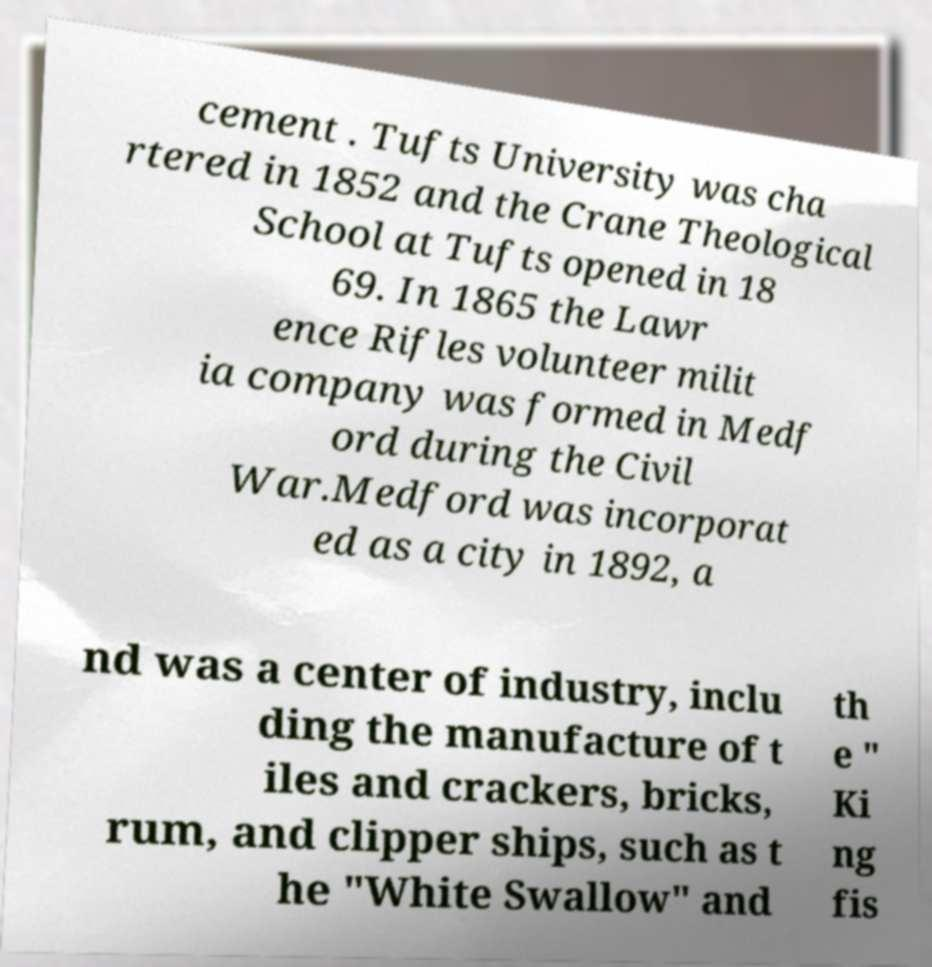Could you extract and type out the text from this image? cement . Tufts University was cha rtered in 1852 and the Crane Theological School at Tufts opened in 18 69. In 1865 the Lawr ence Rifles volunteer milit ia company was formed in Medf ord during the Civil War.Medford was incorporat ed as a city in 1892, a nd was a center of industry, inclu ding the manufacture of t iles and crackers, bricks, rum, and clipper ships, such as t he "White Swallow" and th e " Ki ng fis 